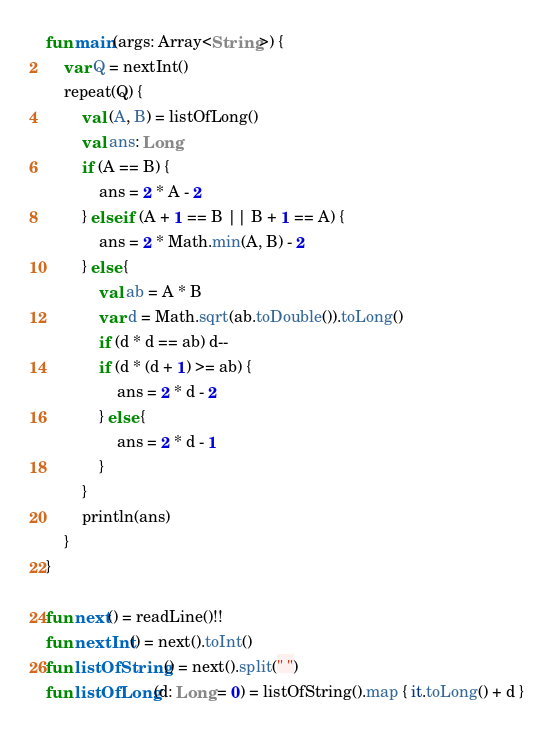<code> <loc_0><loc_0><loc_500><loc_500><_Kotlin_>fun main(args: Array<String>) {
    var Q = nextInt()
    repeat(Q) {
        val (A, B) = listOfLong()
        val ans: Long
        if (A == B) {
            ans = 2 * A - 2
        } else if (A + 1 == B || B + 1 == A) {
            ans = 2 * Math.min(A, B) - 2
        } else {
            val ab = A * B
            var d = Math.sqrt(ab.toDouble()).toLong()
            if (d * d == ab) d--
            if (d * (d + 1) >= ab) {
                ans = 2 * d - 2
            } else {
                ans = 2 * d - 1
            }
        }
        println(ans)
    }
}

fun next() = readLine()!!
fun nextInt() = next().toInt()
fun listOfString() = next().split(" ")
fun listOfLong(d: Long = 0) = listOfString().map { it.toLong() + d }
</code> 